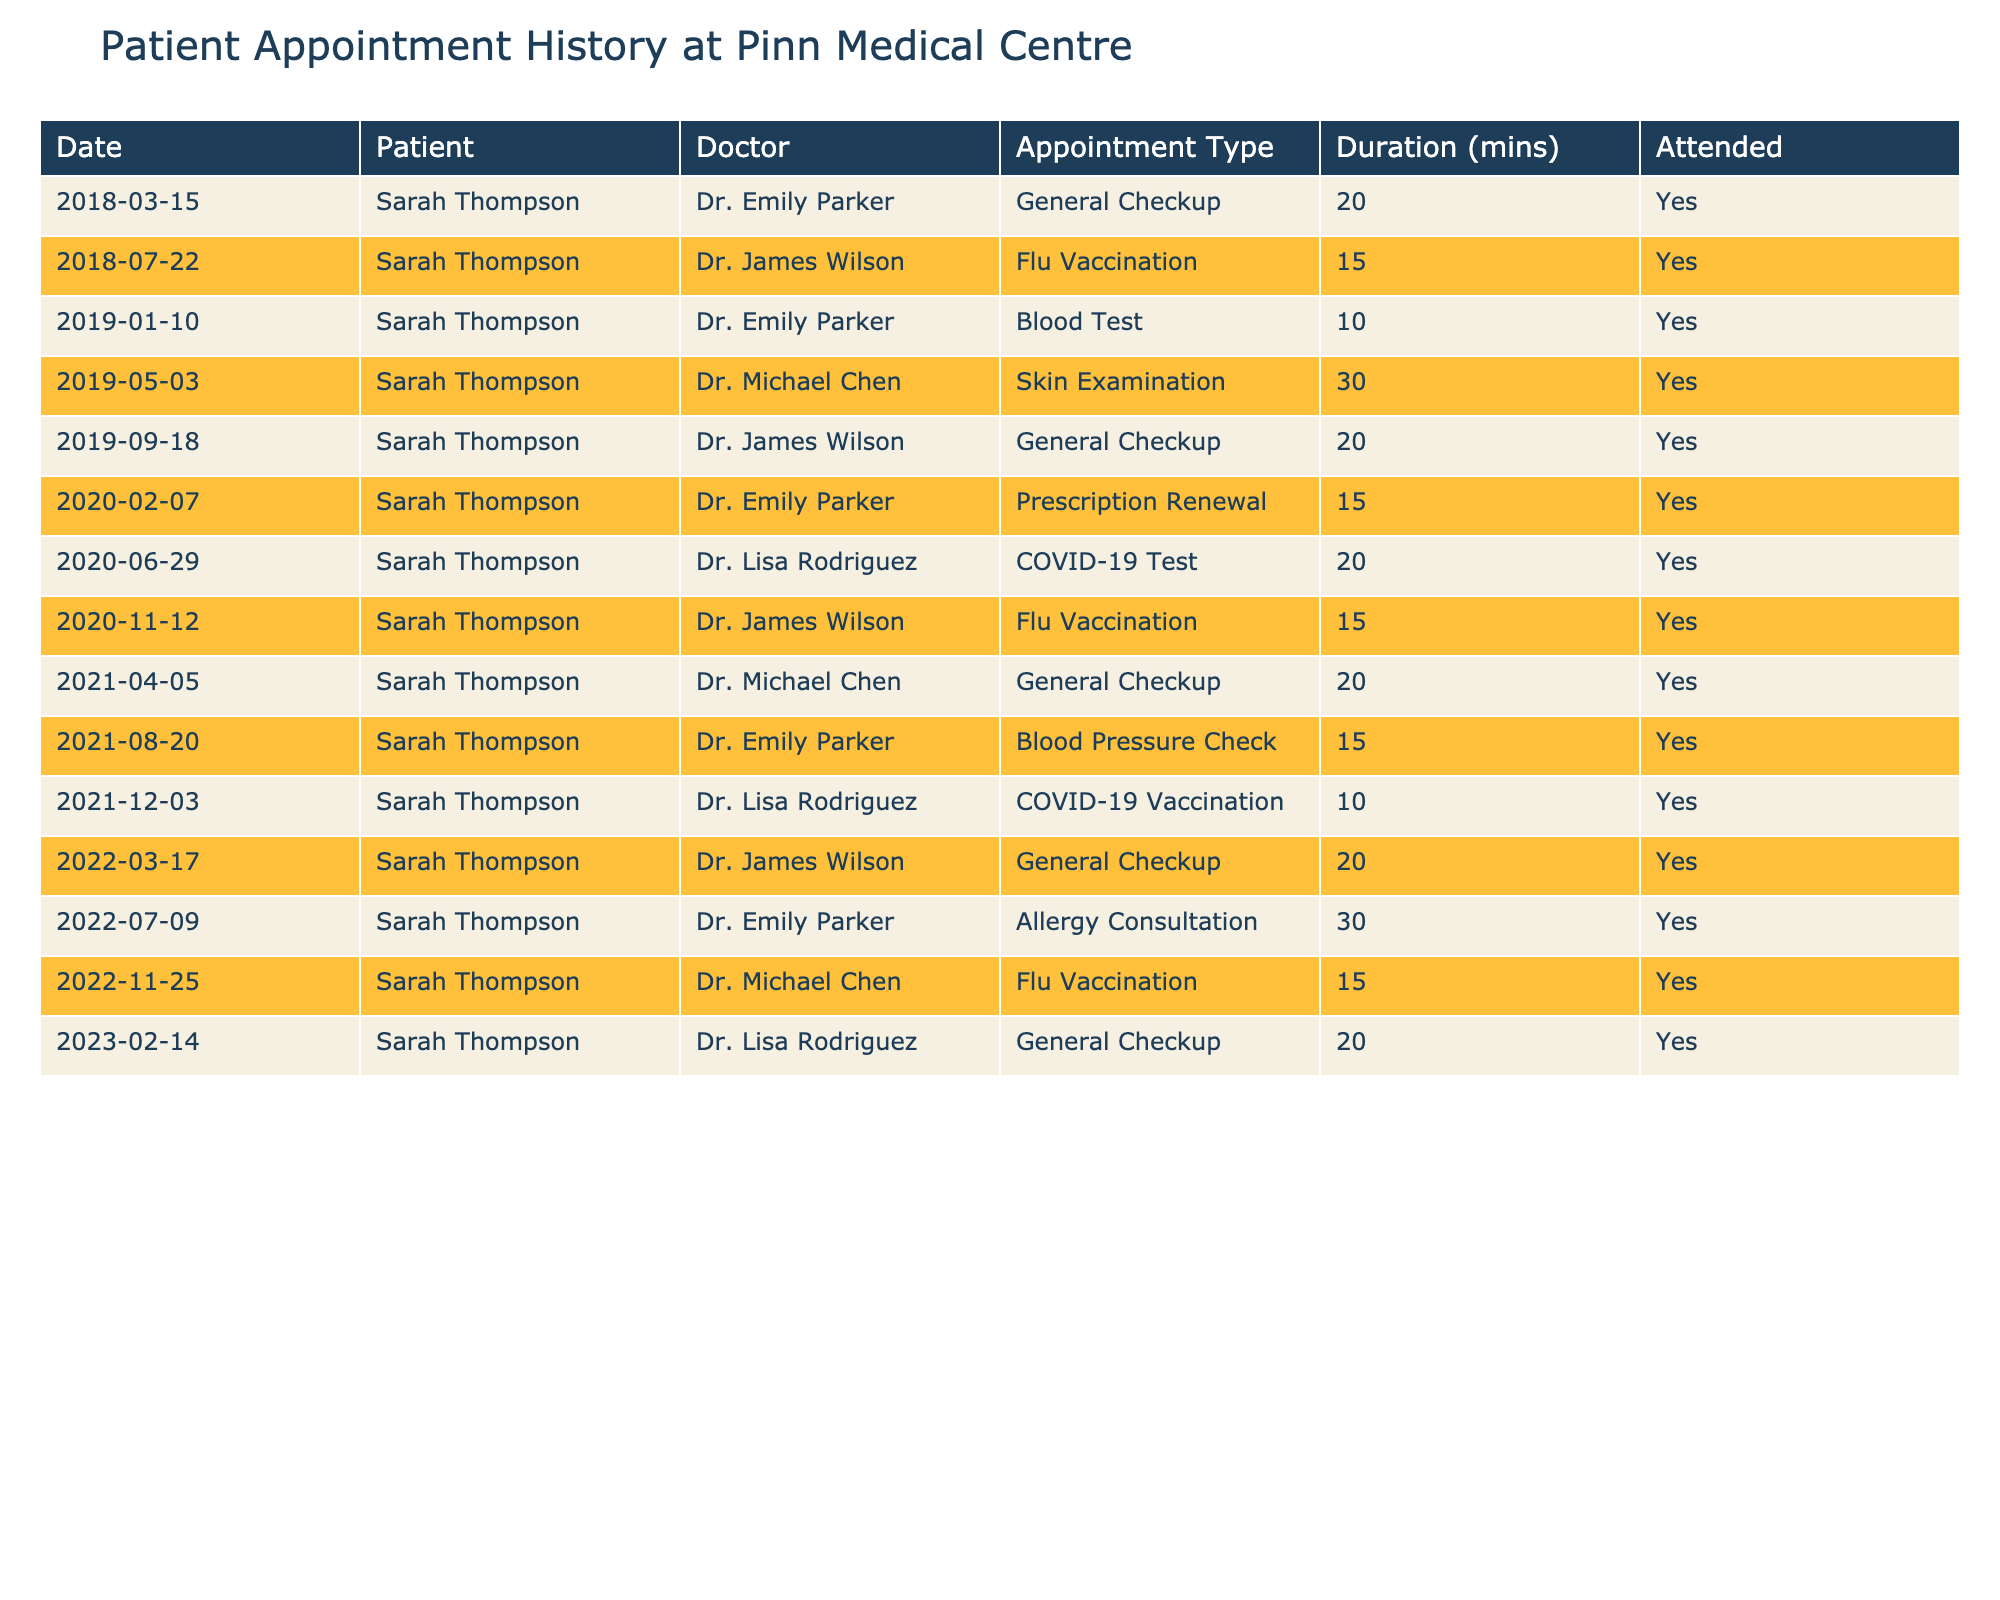What was the duration of Sarah Thompson's longest appointment? In the table, the longest appointment is for the Skin Examination on 2019-05-03, which lasted 30 minutes.
Answer: 30 minutes How many appointments did Sarah Thompson have with Dr. Emily Parker? By counting the entries, Sarah Thompson had 4 appointments with Dr. Emily Parker: on 2018-03-15, 2019-01-10, 2021-08-20, and 2022-07-09.
Answer: 4 Did Sarah Thompson attend all her appointments? The 'Attended' column indicates 'Yes' for all entries, confirming that she attended all her appointments.
Answer: Yes What type of appointment did Sarah Thompson have on 2020-06-29? The table shows that on this date, she had a COVID-19 Test appointment.
Answer: COVID-19 Test How many general checkup appointments has Sarah Thompson attended in total? From the table, Sarah Thompson attended 5 General Checkup appointments: on 2018-03-15, 2019-09-18, 2021-04-05, 2022-03-17, and 2023-02-14.
Answer: 5 What is the average duration of Sarah Thompson's appointments over the last 5 years? The durations of the appointments are 20, 15, 10, 30, 20, 15, 20, 20, 15, 10, 20, 30, 15, and 20 minutes totaling 275 minutes and there are 14 appointments, so the average duration is 275/14 ≈ 19.64 minutes.
Answer: Approximately 19.64 minutes How many times did Sarah Thompson receive vaccinations during her appointments? The table lists 3 vaccinations: Flu Vaccination on 2018-07-22, Flu Vaccination on 2020-11-12, and COVID-19 Vaccination on 2021-12-03, totaling 3 vaccination appointments.
Answer: 3 Which doctor did Sarah Thompson see for her first appointment? The first appointment dated 2018-03-15 was with Dr. Emily Parker for a General Checkup.
Answer: Dr. Emily Parker What percentage of appointments were general checkups? Out of 14 appointments, 5 were General Checkups. Therefore, the percentage is (5/14) * 100 ≈ 35.71%.
Answer: Approximately 35.71% What was the outcome of Sarah Thompson's appointment on 2022-11-25? The table indicates that she attended her appointment on this date for a Flu Vaccination.
Answer: Attended Flu Vaccination Which appointment type did she attend most frequently? The General Checkup appeared 5 times, which is more frequent than any other appointment type in the table.
Answer: General Checkup 